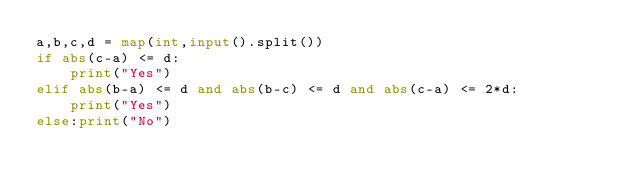Convert code to text. <code><loc_0><loc_0><loc_500><loc_500><_Python_>a,b,c,d = map(int,input().split())
if abs(c-a) <= d:
    print("Yes")
elif abs(b-a) <= d and abs(b-c) <= d and abs(c-a) <= 2*d:
    print("Yes")
else:print("No")</code> 